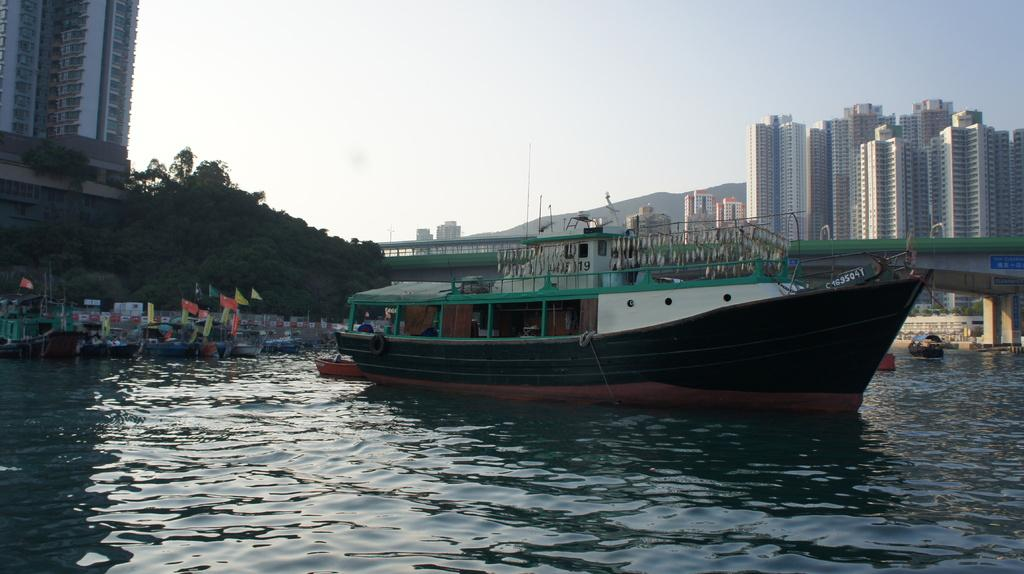Provide a one-sentence caption for the provided image. A medium sized boat with C 163504Y on the front of it. 